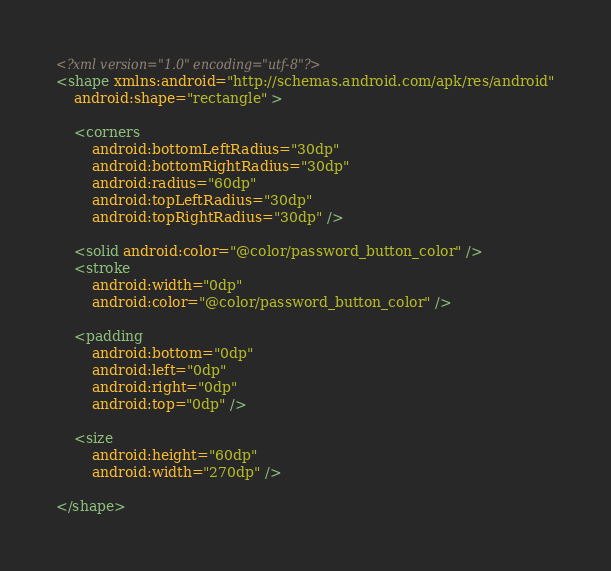<code> <loc_0><loc_0><loc_500><loc_500><_XML_><?xml version="1.0" encoding="utf-8"?>
<shape xmlns:android="http://schemas.android.com/apk/res/android"
    android:shape="rectangle" >

    <corners
        android:bottomLeftRadius="30dp"
        android:bottomRightRadius="30dp"
        android:radius="60dp"
        android:topLeftRadius="30dp"
        android:topRightRadius="30dp" />

    <solid android:color="@color/password_button_color" />
    <stroke
        android:width="0dp"
        android:color="@color/password_button_color" />

    <padding
        android:bottom="0dp"
        android:left="0dp"
        android:right="0dp"
        android:top="0dp" />

    <size
        android:height="60dp"
        android:width="270dp" />

</shape></code> 